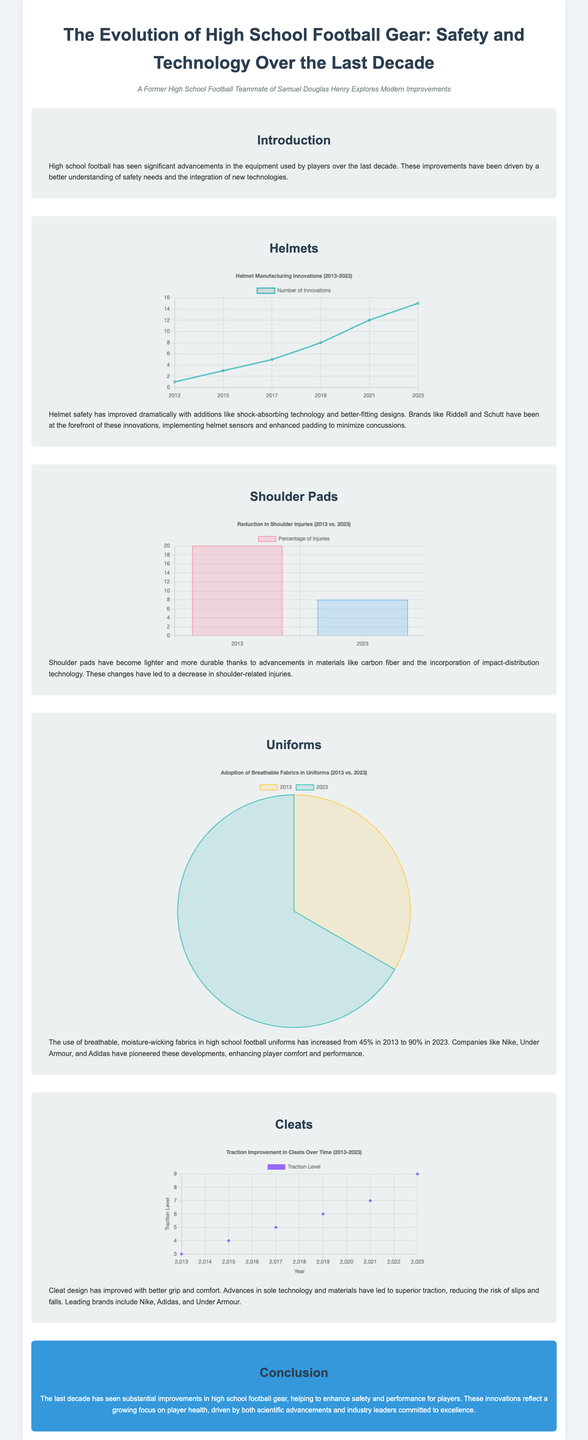What has been the percentage increase in the use of breathable fabrics in uniforms from 2013 to 2023? The document states that the use of breathable fabrics in uniforms increased from 45% in 2013 to 90% in 2023, which means a 45% increase.
Answer: 45% Which brands are mentioned as leaders in helmet innovations? The document specifically mentions Riddell and Schutt as being at the forefront of helmet innovations.
Answer: Riddell and Schutt What was the percentage of shoulder-related injuries in 2013? According to the shoulder pad chart in the document, the percentage of shoulder-related injuries in 2013 was 20%.
Answer: 20% What type of chart is used to represent innovations in helmet manufacturing? The document notes that a line chart is used for presenting innovations in helmet manufacturing over the years.
Answer: Line chart In what year did the traction level in cleats reach 9? The document indicates that the traction level in cleats reached 9 in the year 2023.
Answer: 2023 What material advancements contributed to lighter shoulder pads? The document points out that advancements in materials like carbon fiber contributed to the lighter shoulder pads.
Answer: Carbon fiber What were the two years compared in the shoulder pad injury reduction chart? The document states that the years 2013 and 2023 are compared in the shoulder pad injury reduction chart.
Answer: 2013 and 2023 How many innovations in helmet manufacturing were recorded in 2021? The document provides that there were 12 innovations in helmet manufacturing recorded in 2021.
Answer: 12 What type of chart represents the adoption of breathable fabrics in uniforms? The document specifies that a pie chart is utilized to represent the adoption of breathable fabrics in uniforms.
Answer: Pie chart 